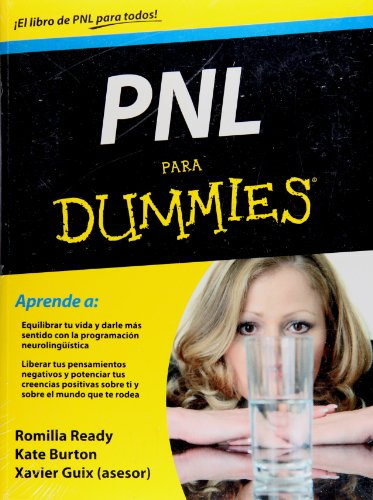Is this a kids book? No, this is not a book for children. It caters to adults seeking self-improvement techniques and is part of the 'For Dummies' series, which offers introductory guides on a wide range of topics. 